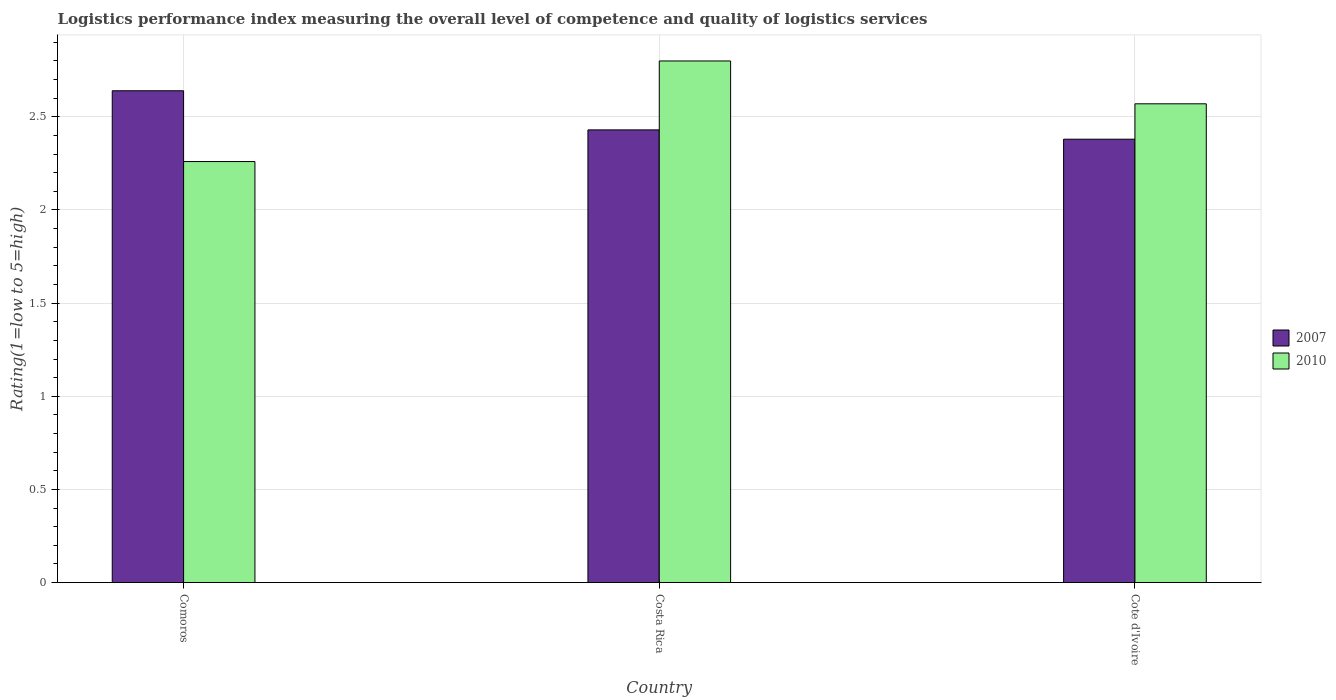How many different coloured bars are there?
Keep it short and to the point. 2. How many groups of bars are there?
Make the answer very short. 3. Are the number of bars per tick equal to the number of legend labels?
Your response must be concise. Yes. How many bars are there on the 1st tick from the right?
Your response must be concise. 2. What is the Logistic performance index in 2007 in Costa Rica?
Offer a very short reply. 2.43. Across all countries, what is the maximum Logistic performance index in 2007?
Your response must be concise. 2.64. Across all countries, what is the minimum Logistic performance index in 2010?
Your response must be concise. 2.26. In which country was the Logistic performance index in 2010 minimum?
Provide a short and direct response. Comoros. What is the total Logistic performance index in 2010 in the graph?
Ensure brevity in your answer.  7.63. What is the difference between the Logistic performance index in 2010 in Comoros and that in Costa Rica?
Give a very brief answer. -0.54. What is the difference between the Logistic performance index in 2010 in Comoros and the Logistic performance index in 2007 in Cote d'Ivoire?
Give a very brief answer. -0.12. What is the average Logistic performance index in 2007 per country?
Ensure brevity in your answer.  2.48. What is the difference between the Logistic performance index of/in 2007 and Logistic performance index of/in 2010 in Comoros?
Ensure brevity in your answer.  0.38. What is the ratio of the Logistic performance index in 2010 in Comoros to that in Cote d'Ivoire?
Offer a very short reply. 0.88. Is the Logistic performance index in 2007 in Comoros less than that in Cote d'Ivoire?
Offer a terse response. No. Is the difference between the Logistic performance index in 2007 in Comoros and Costa Rica greater than the difference between the Logistic performance index in 2010 in Comoros and Costa Rica?
Keep it short and to the point. Yes. What is the difference between the highest and the second highest Logistic performance index in 2007?
Ensure brevity in your answer.  0.21. What is the difference between the highest and the lowest Logistic performance index in 2007?
Keep it short and to the point. 0.26. What does the 2nd bar from the right in Comoros represents?
Your answer should be very brief. 2007. Are all the bars in the graph horizontal?
Your answer should be very brief. No. Does the graph contain grids?
Give a very brief answer. Yes. Where does the legend appear in the graph?
Provide a short and direct response. Center right. How many legend labels are there?
Offer a very short reply. 2. How are the legend labels stacked?
Give a very brief answer. Vertical. What is the title of the graph?
Give a very brief answer. Logistics performance index measuring the overall level of competence and quality of logistics services. Does "1993" appear as one of the legend labels in the graph?
Offer a very short reply. No. What is the label or title of the Y-axis?
Ensure brevity in your answer.  Rating(1=low to 5=high). What is the Rating(1=low to 5=high) of 2007 in Comoros?
Your answer should be very brief. 2.64. What is the Rating(1=low to 5=high) of 2010 in Comoros?
Offer a terse response. 2.26. What is the Rating(1=low to 5=high) of 2007 in Costa Rica?
Your answer should be compact. 2.43. What is the Rating(1=low to 5=high) in 2010 in Costa Rica?
Give a very brief answer. 2.8. What is the Rating(1=low to 5=high) of 2007 in Cote d'Ivoire?
Keep it short and to the point. 2.38. What is the Rating(1=low to 5=high) of 2010 in Cote d'Ivoire?
Ensure brevity in your answer.  2.57. Across all countries, what is the maximum Rating(1=low to 5=high) of 2007?
Provide a succinct answer. 2.64. Across all countries, what is the minimum Rating(1=low to 5=high) of 2007?
Ensure brevity in your answer.  2.38. Across all countries, what is the minimum Rating(1=low to 5=high) in 2010?
Offer a terse response. 2.26. What is the total Rating(1=low to 5=high) in 2007 in the graph?
Make the answer very short. 7.45. What is the total Rating(1=low to 5=high) in 2010 in the graph?
Your response must be concise. 7.63. What is the difference between the Rating(1=low to 5=high) of 2007 in Comoros and that in Costa Rica?
Give a very brief answer. 0.21. What is the difference between the Rating(1=low to 5=high) of 2010 in Comoros and that in Costa Rica?
Provide a succinct answer. -0.54. What is the difference between the Rating(1=low to 5=high) of 2007 in Comoros and that in Cote d'Ivoire?
Give a very brief answer. 0.26. What is the difference between the Rating(1=low to 5=high) of 2010 in Comoros and that in Cote d'Ivoire?
Offer a terse response. -0.31. What is the difference between the Rating(1=low to 5=high) in 2010 in Costa Rica and that in Cote d'Ivoire?
Your answer should be compact. 0.23. What is the difference between the Rating(1=low to 5=high) in 2007 in Comoros and the Rating(1=low to 5=high) in 2010 in Costa Rica?
Provide a short and direct response. -0.16. What is the difference between the Rating(1=low to 5=high) in 2007 in Comoros and the Rating(1=low to 5=high) in 2010 in Cote d'Ivoire?
Keep it short and to the point. 0.07. What is the difference between the Rating(1=low to 5=high) in 2007 in Costa Rica and the Rating(1=low to 5=high) in 2010 in Cote d'Ivoire?
Your answer should be compact. -0.14. What is the average Rating(1=low to 5=high) of 2007 per country?
Ensure brevity in your answer.  2.48. What is the average Rating(1=low to 5=high) in 2010 per country?
Offer a very short reply. 2.54. What is the difference between the Rating(1=low to 5=high) of 2007 and Rating(1=low to 5=high) of 2010 in Comoros?
Give a very brief answer. 0.38. What is the difference between the Rating(1=low to 5=high) of 2007 and Rating(1=low to 5=high) of 2010 in Costa Rica?
Provide a succinct answer. -0.37. What is the difference between the Rating(1=low to 5=high) in 2007 and Rating(1=low to 5=high) in 2010 in Cote d'Ivoire?
Offer a very short reply. -0.19. What is the ratio of the Rating(1=low to 5=high) of 2007 in Comoros to that in Costa Rica?
Provide a succinct answer. 1.09. What is the ratio of the Rating(1=low to 5=high) in 2010 in Comoros to that in Costa Rica?
Make the answer very short. 0.81. What is the ratio of the Rating(1=low to 5=high) in 2007 in Comoros to that in Cote d'Ivoire?
Ensure brevity in your answer.  1.11. What is the ratio of the Rating(1=low to 5=high) in 2010 in Comoros to that in Cote d'Ivoire?
Offer a very short reply. 0.88. What is the ratio of the Rating(1=low to 5=high) in 2007 in Costa Rica to that in Cote d'Ivoire?
Offer a terse response. 1.02. What is the ratio of the Rating(1=low to 5=high) in 2010 in Costa Rica to that in Cote d'Ivoire?
Offer a terse response. 1.09. What is the difference between the highest and the second highest Rating(1=low to 5=high) of 2007?
Offer a very short reply. 0.21. What is the difference between the highest and the second highest Rating(1=low to 5=high) in 2010?
Your response must be concise. 0.23. What is the difference between the highest and the lowest Rating(1=low to 5=high) of 2007?
Your response must be concise. 0.26. What is the difference between the highest and the lowest Rating(1=low to 5=high) of 2010?
Your answer should be compact. 0.54. 